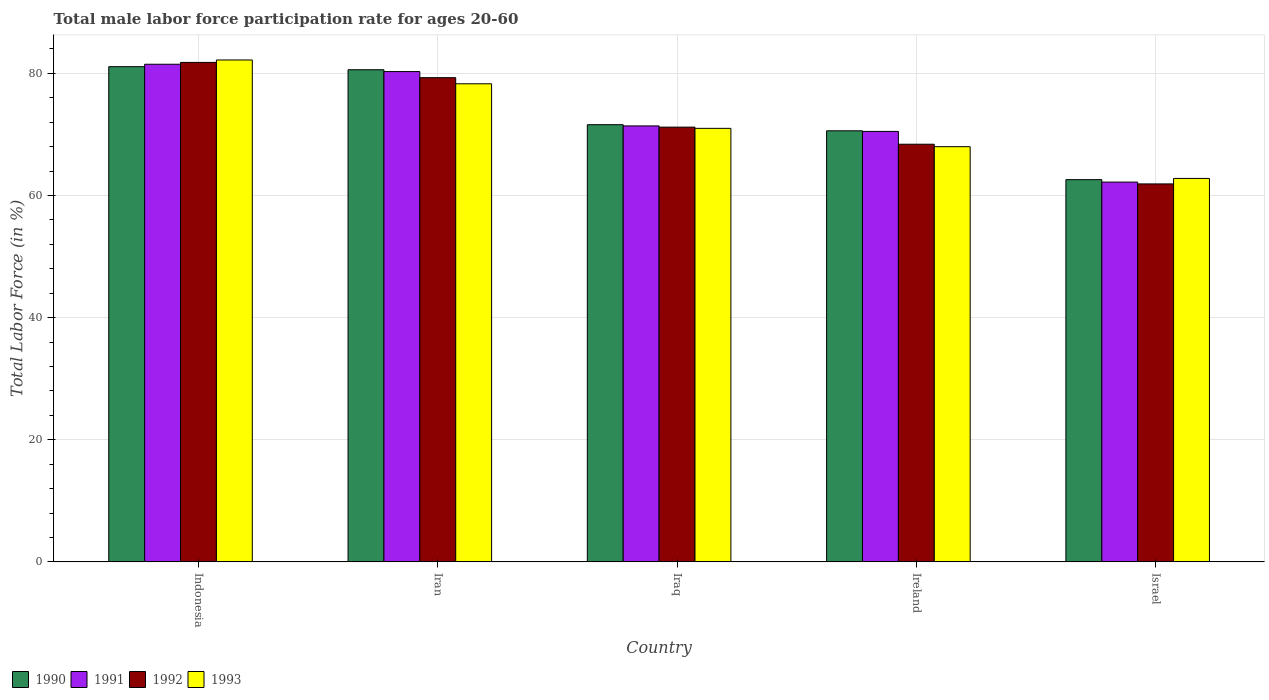How many groups of bars are there?
Provide a succinct answer. 5. Are the number of bars per tick equal to the number of legend labels?
Your answer should be compact. Yes. Are the number of bars on each tick of the X-axis equal?
Your answer should be very brief. Yes. How many bars are there on the 3rd tick from the right?
Ensure brevity in your answer.  4. What is the label of the 2nd group of bars from the left?
Provide a short and direct response. Iran. In how many cases, is the number of bars for a given country not equal to the number of legend labels?
Your response must be concise. 0. What is the male labor force participation rate in 1990 in Iraq?
Make the answer very short. 71.6. Across all countries, what is the maximum male labor force participation rate in 1991?
Keep it short and to the point. 81.5. Across all countries, what is the minimum male labor force participation rate in 1992?
Your response must be concise. 61.9. In which country was the male labor force participation rate in 1991 maximum?
Make the answer very short. Indonesia. In which country was the male labor force participation rate in 1991 minimum?
Provide a succinct answer. Israel. What is the total male labor force participation rate in 1991 in the graph?
Give a very brief answer. 365.9. What is the difference between the male labor force participation rate in 1993 in Indonesia and that in Iraq?
Provide a short and direct response. 11.2. What is the difference between the male labor force participation rate in 1990 in Ireland and the male labor force participation rate in 1992 in Israel?
Give a very brief answer. 8.7. What is the average male labor force participation rate in 1991 per country?
Make the answer very short. 73.18. What is the difference between the male labor force participation rate of/in 1993 and male labor force participation rate of/in 1990 in Ireland?
Offer a terse response. -2.6. In how many countries, is the male labor force participation rate in 1991 greater than 44 %?
Keep it short and to the point. 5. What is the ratio of the male labor force participation rate in 1991 in Iraq to that in Ireland?
Your answer should be compact. 1.01. Is the male labor force participation rate in 1990 in Iraq less than that in Israel?
Your answer should be compact. No. What is the difference between the highest and the second highest male labor force participation rate in 1992?
Offer a very short reply. 10.6. What is the difference between the highest and the lowest male labor force participation rate in 1993?
Provide a short and direct response. 19.4. In how many countries, is the male labor force participation rate in 1992 greater than the average male labor force participation rate in 1992 taken over all countries?
Offer a very short reply. 2. Is the sum of the male labor force participation rate in 1992 in Ireland and Israel greater than the maximum male labor force participation rate in 1991 across all countries?
Provide a succinct answer. Yes. What does the 2nd bar from the right in Israel represents?
Your response must be concise. 1992. Is it the case that in every country, the sum of the male labor force participation rate in 1993 and male labor force participation rate in 1991 is greater than the male labor force participation rate in 1992?
Provide a succinct answer. Yes. How many countries are there in the graph?
Make the answer very short. 5. Are the values on the major ticks of Y-axis written in scientific E-notation?
Provide a succinct answer. No. Where does the legend appear in the graph?
Offer a very short reply. Bottom left. What is the title of the graph?
Give a very brief answer. Total male labor force participation rate for ages 20-60. Does "2015" appear as one of the legend labels in the graph?
Keep it short and to the point. No. What is the label or title of the Y-axis?
Offer a terse response. Total Labor Force (in %). What is the Total Labor Force (in %) in 1990 in Indonesia?
Provide a short and direct response. 81.1. What is the Total Labor Force (in %) of 1991 in Indonesia?
Keep it short and to the point. 81.5. What is the Total Labor Force (in %) of 1992 in Indonesia?
Your response must be concise. 81.8. What is the Total Labor Force (in %) in 1993 in Indonesia?
Provide a short and direct response. 82.2. What is the Total Labor Force (in %) in 1990 in Iran?
Provide a short and direct response. 80.6. What is the Total Labor Force (in %) in 1991 in Iran?
Offer a terse response. 80.3. What is the Total Labor Force (in %) in 1992 in Iran?
Your response must be concise. 79.3. What is the Total Labor Force (in %) of 1993 in Iran?
Offer a very short reply. 78.3. What is the Total Labor Force (in %) in 1990 in Iraq?
Make the answer very short. 71.6. What is the Total Labor Force (in %) in 1991 in Iraq?
Provide a short and direct response. 71.4. What is the Total Labor Force (in %) of 1992 in Iraq?
Provide a short and direct response. 71.2. What is the Total Labor Force (in %) in 1993 in Iraq?
Make the answer very short. 71. What is the Total Labor Force (in %) of 1990 in Ireland?
Your answer should be very brief. 70.6. What is the Total Labor Force (in %) of 1991 in Ireland?
Keep it short and to the point. 70.5. What is the Total Labor Force (in %) of 1992 in Ireland?
Offer a very short reply. 68.4. What is the Total Labor Force (in %) of 1993 in Ireland?
Your answer should be compact. 68. What is the Total Labor Force (in %) in 1990 in Israel?
Provide a short and direct response. 62.6. What is the Total Labor Force (in %) of 1991 in Israel?
Your answer should be very brief. 62.2. What is the Total Labor Force (in %) in 1992 in Israel?
Keep it short and to the point. 61.9. What is the Total Labor Force (in %) in 1993 in Israel?
Your answer should be compact. 62.8. Across all countries, what is the maximum Total Labor Force (in %) in 1990?
Make the answer very short. 81.1. Across all countries, what is the maximum Total Labor Force (in %) of 1991?
Provide a short and direct response. 81.5. Across all countries, what is the maximum Total Labor Force (in %) in 1992?
Keep it short and to the point. 81.8. Across all countries, what is the maximum Total Labor Force (in %) of 1993?
Provide a short and direct response. 82.2. Across all countries, what is the minimum Total Labor Force (in %) in 1990?
Keep it short and to the point. 62.6. Across all countries, what is the minimum Total Labor Force (in %) of 1991?
Your answer should be very brief. 62.2. Across all countries, what is the minimum Total Labor Force (in %) of 1992?
Your answer should be compact. 61.9. Across all countries, what is the minimum Total Labor Force (in %) in 1993?
Keep it short and to the point. 62.8. What is the total Total Labor Force (in %) of 1990 in the graph?
Your answer should be compact. 366.5. What is the total Total Labor Force (in %) of 1991 in the graph?
Make the answer very short. 365.9. What is the total Total Labor Force (in %) in 1992 in the graph?
Provide a succinct answer. 362.6. What is the total Total Labor Force (in %) in 1993 in the graph?
Offer a terse response. 362.3. What is the difference between the Total Labor Force (in %) in 1990 in Indonesia and that in Iran?
Make the answer very short. 0.5. What is the difference between the Total Labor Force (in %) in 1991 in Indonesia and that in Iran?
Offer a very short reply. 1.2. What is the difference between the Total Labor Force (in %) of 1991 in Indonesia and that in Iraq?
Give a very brief answer. 10.1. What is the difference between the Total Labor Force (in %) in 1992 in Indonesia and that in Iraq?
Provide a succinct answer. 10.6. What is the difference between the Total Labor Force (in %) in 1993 in Indonesia and that in Iraq?
Ensure brevity in your answer.  11.2. What is the difference between the Total Labor Force (in %) in 1991 in Indonesia and that in Ireland?
Give a very brief answer. 11. What is the difference between the Total Labor Force (in %) of 1993 in Indonesia and that in Ireland?
Give a very brief answer. 14.2. What is the difference between the Total Labor Force (in %) of 1991 in Indonesia and that in Israel?
Give a very brief answer. 19.3. What is the difference between the Total Labor Force (in %) in 1992 in Indonesia and that in Israel?
Your answer should be very brief. 19.9. What is the difference between the Total Labor Force (in %) in 1993 in Indonesia and that in Israel?
Offer a very short reply. 19.4. What is the difference between the Total Labor Force (in %) in 1991 in Iran and that in Iraq?
Make the answer very short. 8.9. What is the difference between the Total Labor Force (in %) of 1993 in Iran and that in Iraq?
Your response must be concise. 7.3. What is the difference between the Total Labor Force (in %) in 1990 in Iran and that in Ireland?
Keep it short and to the point. 10. What is the difference between the Total Labor Force (in %) of 1990 in Iran and that in Israel?
Provide a short and direct response. 18. What is the difference between the Total Labor Force (in %) in 1991 in Iran and that in Israel?
Keep it short and to the point. 18.1. What is the difference between the Total Labor Force (in %) in 1992 in Iran and that in Israel?
Give a very brief answer. 17.4. What is the difference between the Total Labor Force (in %) of 1993 in Iran and that in Israel?
Provide a succinct answer. 15.5. What is the difference between the Total Labor Force (in %) in 1990 in Iraq and that in Ireland?
Your response must be concise. 1. What is the difference between the Total Labor Force (in %) of 1991 in Iraq and that in Ireland?
Ensure brevity in your answer.  0.9. What is the difference between the Total Labor Force (in %) of 1993 in Iraq and that in Ireland?
Your answer should be very brief. 3. What is the difference between the Total Labor Force (in %) of 1990 in Iraq and that in Israel?
Provide a succinct answer. 9. What is the difference between the Total Labor Force (in %) in 1991 in Iraq and that in Israel?
Offer a terse response. 9.2. What is the difference between the Total Labor Force (in %) in 1992 in Iraq and that in Israel?
Your response must be concise. 9.3. What is the difference between the Total Labor Force (in %) in 1993 in Iraq and that in Israel?
Your response must be concise. 8.2. What is the difference between the Total Labor Force (in %) of 1991 in Ireland and that in Israel?
Provide a short and direct response. 8.3. What is the difference between the Total Labor Force (in %) in 1993 in Ireland and that in Israel?
Make the answer very short. 5.2. What is the difference between the Total Labor Force (in %) of 1990 in Indonesia and the Total Labor Force (in %) of 1992 in Iran?
Keep it short and to the point. 1.8. What is the difference between the Total Labor Force (in %) in 1991 in Indonesia and the Total Labor Force (in %) in 1992 in Iran?
Your answer should be compact. 2.2. What is the difference between the Total Labor Force (in %) in 1992 in Indonesia and the Total Labor Force (in %) in 1993 in Iran?
Offer a terse response. 3.5. What is the difference between the Total Labor Force (in %) of 1991 in Indonesia and the Total Labor Force (in %) of 1992 in Iraq?
Your answer should be compact. 10.3. What is the difference between the Total Labor Force (in %) of 1992 in Indonesia and the Total Labor Force (in %) of 1993 in Iraq?
Your answer should be compact. 10.8. What is the difference between the Total Labor Force (in %) in 1990 in Indonesia and the Total Labor Force (in %) in 1991 in Ireland?
Your answer should be compact. 10.6. What is the difference between the Total Labor Force (in %) of 1990 in Indonesia and the Total Labor Force (in %) of 1992 in Ireland?
Your answer should be very brief. 12.7. What is the difference between the Total Labor Force (in %) in 1990 in Indonesia and the Total Labor Force (in %) in 1993 in Ireland?
Provide a short and direct response. 13.1. What is the difference between the Total Labor Force (in %) of 1991 in Indonesia and the Total Labor Force (in %) of 1992 in Ireland?
Your answer should be compact. 13.1. What is the difference between the Total Labor Force (in %) in 1991 in Indonesia and the Total Labor Force (in %) in 1993 in Ireland?
Offer a terse response. 13.5. What is the difference between the Total Labor Force (in %) of 1990 in Indonesia and the Total Labor Force (in %) of 1992 in Israel?
Provide a succinct answer. 19.2. What is the difference between the Total Labor Force (in %) of 1991 in Indonesia and the Total Labor Force (in %) of 1992 in Israel?
Your response must be concise. 19.6. What is the difference between the Total Labor Force (in %) of 1992 in Indonesia and the Total Labor Force (in %) of 1993 in Israel?
Provide a succinct answer. 19. What is the difference between the Total Labor Force (in %) in 1990 in Iran and the Total Labor Force (in %) in 1992 in Iraq?
Your response must be concise. 9.4. What is the difference between the Total Labor Force (in %) in 1991 in Iran and the Total Labor Force (in %) in 1992 in Iraq?
Provide a succinct answer. 9.1. What is the difference between the Total Labor Force (in %) of 1991 in Iran and the Total Labor Force (in %) of 1993 in Iraq?
Offer a terse response. 9.3. What is the difference between the Total Labor Force (in %) in 1991 in Iran and the Total Labor Force (in %) in 1992 in Ireland?
Make the answer very short. 11.9. What is the difference between the Total Labor Force (in %) of 1991 in Iran and the Total Labor Force (in %) of 1993 in Ireland?
Offer a very short reply. 12.3. What is the difference between the Total Labor Force (in %) of 1990 in Iran and the Total Labor Force (in %) of 1991 in Israel?
Give a very brief answer. 18.4. What is the difference between the Total Labor Force (in %) of 1990 in Iran and the Total Labor Force (in %) of 1992 in Israel?
Your answer should be compact. 18.7. What is the difference between the Total Labor Force (in %) in 1990 in Iran and the Total Labor Force (in %) in 1993 in Israel?
Offer a very short reply. 17.8. What is the difference between the Total Labor Force (in %) in 1991 in Iran and the Total Labor Force (in %) in 1992 in Israel?
Your answer should be very brief. 18.4. What is the difference between the Total Labor Force (in %) of 1992 in Iran and the Total Labor Force (in %) of 1993 in Israel?
Your answer should be very brief. 16.5. What is the difference between the Total Labor Force (in %) in 1990 in Iraq and the Total Labor Force (in %) in 1993 in Ireland?
Your answer should be very brief. 3.6. What is the difference between the Total Labor Force (in %) in 1991 in Iraq and the Total Labor Force (in %) in 1993 in Ireland?
Your response must be concise. 3.4. What is the difference between the Total Labor Force (in %) in 1992 in Iraq and the Total Labor Force (in %) in 1993 in Ireland?
Your answer should be compact. 3.2. What is the difference between the Total Labor Force (in %) in 1990 in Iraq and the Total Labor Force (in %) in 1991 in Israel?
Make the answer very short. 9.4. What is the difference between the Total Labor Force (in %) in 1990 in Ireland and the Total Labor Force (in %) in 1991 in Israel?
Your answer should be compact. 8.4. What is the difference between the Total Labor Force (in %) of 1990 in Ireland and the Total Labor Force (in %) of 1992 in Israel?
Offer a terse response. 8.7. What is the difference between the Total Labor Force (in %) of 1990 in Ireland and the Total Labor Force (in %) of 1993 in Israel?
Your answer should be compact. 7.8. What is the difference between the Total Labor Force (in %) of 1991 in Ireland and the Total Labor Force (in %) of 1993 in Israel?
Make the answer very short. 7.7. What is the difference between the Total Labor Force (in %) in 1992 in Ireland and the Total Labor Force (in %) in 1993 in Israel?
Offer a terse response. 5.6. What is the average Total Labor Force (in %) in 1990 per country?
Your response must be concise. 73.3. What is the average Total Labor Force (in %) in 1991 per country?
Make the answer very short. 73.18. What is the average Total Labor Force (in %) in 1992 per country?
Give a very brief answer. 72.52. What is the average Total Labor Force (in %) in 1993 per country?
Ensure brevity in your answer.  72.46. What is the difference between the Total Labor Force (in %) in 1990 and Total Labor Force (in %) in 1991 in Iran?
Your answer should be compact. 0.3. What is the difference between the Total Labor Force (in %) in 1991 and Total Labor Force (in %) in 1992 in Iran?
Ensure brevity in your answer.  1. What is the difference between the Total Labor Force (in %) in 1991 and Total Labor Force (in %) in 1993 in Iran?
Keep it short and to the point. 2. What is the difference between the Total Labor Force (in %) of 1992 and Total Labor Force (in %) of 1993 in Iran?
Ensure brevity in your answer.  1. What is the difference between the Total Labor Force (in %) of 1990 and Total Labor Force (in %) of 1991 in Iraq?
Provide a succinct answer. 0.2. What is the difference between the Total Labor Force (in %) in 1990 and Total Labor Force (in %) in 1992 in Iraq?
Provide a short and direct response. 0.4. What is the difference between the Total Labor Force (in %) of 1991 and Total Labor Force (in %) of 1992 in Iraq?
Your answer should be very brief. 0.2. What is the difference between the Total Labor Force (in %) in 1991 and Total Labor Force (in %) in 1993 in Iraq?
Your answer should be very brief. 0.4. What is the difference between the Total Labor Force (in %) of 1992 and Total Labor Force (in %) of 1993 in Iraq?
Ensure brevity in your answer.  0.2. What is the difference between the Total Labor Force (in %) of 1990 and Total Labor Force (in %) of 1991 in Ireland?
Keep it short and to the point. 0.1. What is the difference between the Total Labor Force (in %) in 1992 and Total Labor Force (in %) in 1993 in Ireland?
Ensure brevity in your answer.  0.4. What is the difference between the Total Labor Force (in %) of 1990 and Total Labor Force (in %) of 1991 in Israel?
Give a very brief answer. 0.4. What is the difference between the Total Labor Force (in %) of 1990 and Total Labor Force (in %) of 1992 in Israel?
Ensure brevity in your answer.  0.7. What is the difference between the Total Labor Force (in %) of 1991 and Total Labor Force (in %) of 1992 in Israel?
Your response must be concise. 0.3. What is the difference between the Total Labor Force (in %) in 1992 and Total Labor Force (in %) in 1993 in Israel?
Your answer should be compact. -0.9. What is the ratio of the Total Labor Force (in %) in 1990 in Indonesia to that in Iran?
Provide a succinct answer. 1.01. What is the ratio of the Total Labor Force (in %) of 1991 in Indonesia to that in Iran?
Provide a succinct answer. 1.01. What is the ratio of the Total Labor Force (in %) of 1992 in Indonesia to that in Iran?
Offer a terse response. 1.03. What is the ratio of the Total Labor Force (in %) of 1993 in Indonesia to that in Iran?
Make the answer very short. 1.05. What is the ratio of the Total Labor Force (in %) in 1990 in Indonesia to that in Iraq?
Ensure brevity in your answer.  1.13. What is the ratio of the Total Labor Force (in %) of 1991 in Indonesia to that in Iraq?
Ensure brevity in your answer.  1.14. What is the ratio of the Total Labor Force (in %) of 1992 in Indonesia to that in Iraq?
Offer a very short reply. 1.15. What is the ratio of the Total Labor Force (in %) of 1993 in Indonesia to that in Iraq?
Keep it short and to the point. 1.16. What is the ratio of the Total Labor Force (in %) of 1990 in Indonesia to that in Ireland?
Provide a succinct answer. 1.15. What is the ratio of the Total Labor Force (in %) in 1991 in Indonesia to that in Ireland?
Offer a very short reply. 1.16. What is the ratio of the Total Labor Force (in %) of 1992 in Indonesia to that in Ireland?
Give a very brief answer. 1.2. What is the ratio of the Total Labor Force (in %) of 1993 in Indonesia to that in Ireland?
Ensure brevity in your answer.  1.21. What is the ratio of the Total Labor Force (in %) in 1990 in Indonesia to that in Israel?
Keep it short and to the point. 1.3. What is the ratio of the Total Labor Force (in %) in 1991 in Indonesia to that in Israel?
Your answer should be compact. 1.31. What is the ratio of the Total Labor Force (in %) in 1992 in Indonesia to that in Israel?
Provide a succinct answer. 1.32. What is the ratio of the Total Labor Force (in %) of 1993 in Indonesia to that in Israel?
Offer a very short reply. 1.31. What is the ratio of the Total Labor Force (in %) of 1990 in Iran to that in Iraq?
Provide a short and direct response. 1.13. What is the ratio of the Total Labor Force (in %) in 1991 in Iran to that in Iraq?
Offer a very short reply. 1.12. What is the ratio of the Total Labor Force (in %) in 1992 in Iran to that in Iraq?
Your answer should be very brief. 1.11. What is the ratio of the Total Labor Force (in %) in 1993 in Iran to that in Iraq?
Provide a succinct answer. 1.1. What is the ratio of the Total Labor Force (in %) of 1990 in Iran to that in Ireland?
Ensure brevity in your answer.  1.14. What is the ratio of the Total Labor Force (in %) of 1991 in Iran to that in Ireland?
Provide a succinct answer. 1.14. What is the ratio of the Total Labor Force (in %) in 1992 in Iran to that in Ireland?
Provide a short and direct response. 1.16. What is the ratio of the Total Labor Force (in %) in 1993 in Iran to that in Ireland?
Make the answer very short. 1.15. What is the ratio of the Total Labor Force (in %) in 1990 in Iran to that in Israel?
Give a very brief answer. 1.29. What is the ratio of the Total Labor Force (in %) in 1991 in Iran to that in Israel?
Offer a terse response. 1.29. What is the ratio of the Total Labor Force (in %) in 1992 in Iran to that in Israel?
Your response must be concise. 1.28. What is the ratio of the Total Labor Force (in %) in 1993 in Iran to that in Israel?
Ensure brevity in your answer.  1.25. What is the ratio of the Total Labor Force (in %) of 1990 in Iraq to that in Ireland?
Provide a succinct answer. 1.01. What is the ratio of the Total Labor Force (in %) of 1991 in Iraq to that in Ireland?
Offer a very short reply. 1.01. What is the ratio of the Total Labor Force (in %) in 1992 in Iraq to that in Ireland?
Offer a terse response. 1.04. What is the ratio of the Total Labor Force (in %) in 1993 in Iraq to that in Ireland?
Offer a very short reply. 1.04. What is the ratio of the Total Labor Force (in %) of 1990 in Iraq to that in Israel?
Your answer should be compact. 1.14. What is the ratio of the Total Labor Force (in %) in 1991 in Iraq to that in Israel?
Your answer should be compact. 1.15. What is the ratio of the Total Labor Force (in %) in 1992 in Iraq to that in Israel?
Provide a short and direct response. 1.15. What is the ratio of the Total Labor Force (in %) in 1993 in Iraq to that in Israel?
Give a very brief answer. 1.13. What is the ratio of the Total Labor Force (in %) in 1990 in Ireland to that in Israel?
Ensure brevity in your answer.  1.13. What is the ratio of the Total Labor Force (in %) in 1991 in Ireland to that in Israel?
Your answer should be very brief. 1.13. What is the ratio of the Total Labor Force (in %) of 1992 in Ireland to that in Israel?
Offer a very short reply. 1.1. What is the ratio of the Total Labor Force (in %) in 1993 in Ireland to that in Israel?
Your answer should be very brief. 1.08. What is the difference between the highest and the second highest Total Labor Force (in %) of 1991?
Offer a very short reply. 1.2. What is the difference between the highest and the second highest Total Labor Force (in %) in 1993?
Give a very brief answer. 3.9. What is the difference between the highest and the lowest Total Labor Force (in %) of 1990?
Keep it short and to the point. 18.5. What is the difference between the highest and the lowest Total Labor Force (in %) in 1991?
Your answer should be very brief. 19.3. What is the difference between the highest and the lowest Total Labor Force (in %) in 1993?
Offer a terse response. 19.4. 